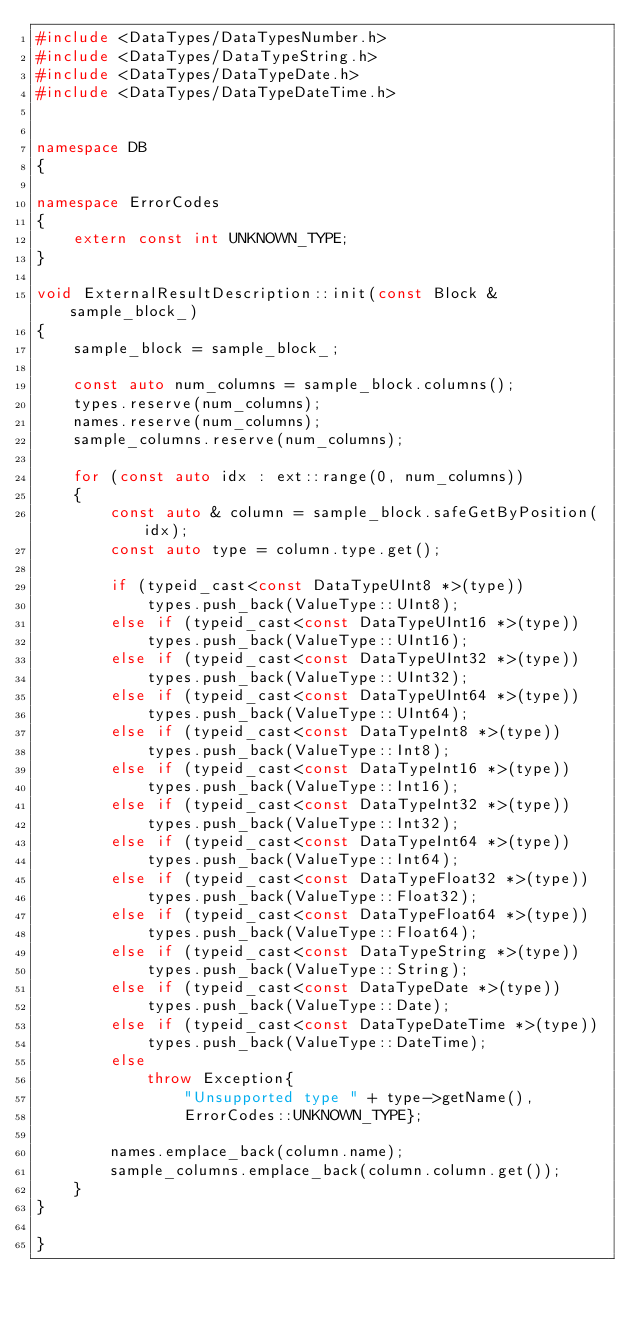Convert code to text. <code><loc_0><loc_0><loc_500><loc_500><_C++_>#include <DataTypes/DataTypesNumber.h>
#include <DataTypes/DataTypeString.h>
#include <DataTypes/DataTypeDate.h>
#include <DataTypes/DataTypeDateTime.h>


namespace DB
{

namespace ErrorCodes
{
    extern const int UNKNOWN_TYPE;
}

void ExternalResultDescription::init(const Block & sample_block_)
{
    sample_block = sample_block_;

    const auto num_columns = sample_block.columns();
    types.reserve(num_columns);
    names.reserve(num_columns);
    sample_columns.reserve(num_columns);

    for (const auto idx : ext::range(0, num_columns))
    {
        const auto & column = sample_block.safeGetByPosition(idx);
        const auto type = column.type.get();

        if (typeid_cast<const DataTypeUInt8 *>(type))
            types.push_back(ValueType::UInt8);
        else if (typeid_cast<const DataTypeUInt16 *>(type))
            types.push_back(ValueType::UInt16);
        else if (typeid_cast<const DataTypeUInt32 *>(type))
            types.push_back(ValueType::UInt32);
        else if (typeid_cast<const DataTypeUInt64 *>(type))
            types.push_back(ValueType::UInt64);
        else if (typeid_cast<const DataTypeInt8 *>(type))
            types.push_back(ValueType::Int8);
        else if (typeid_cast<const DataTypeInt16 *>(type))
            types.push_back(ValueType::Int16);
        else if (typeid_cast<const DataTypeInt32 *>(type))
            types.push_back(ValueType::Int32);
        else if (typeid_cast<const DataTypeInt64 *>(type))
            types.push_back(ValueType::Int64);
        else if (typeid_cast<const DataTypeFloat32 *>(type))
            types.push_back(ValueType::Float32);
        else if (typeid_cast<const DataTypeFloat64 *>(type))
            types.push_back(ValueType::Float64);
        else if (typeid_cast<const DataTypeString *>(type))
            types.push_back(ValueType::String);
        else if (typeid_cast<const DataTypeDate *>(type))
            types.push_back(ValueType::Date);
        else if (typeid_cast<const DataTypeDateTime *>(type))
            types.push_back(ValueType::DateTime);
        else
            throw Exception{
                "Unsupported type " + type->getName(),
                ErrorCodes::UNKNOWN_TYPE};

        names.emplace_back(column.name);
        sample_columns.emplace_back(column.column.get());
    }
}

}
</code> 